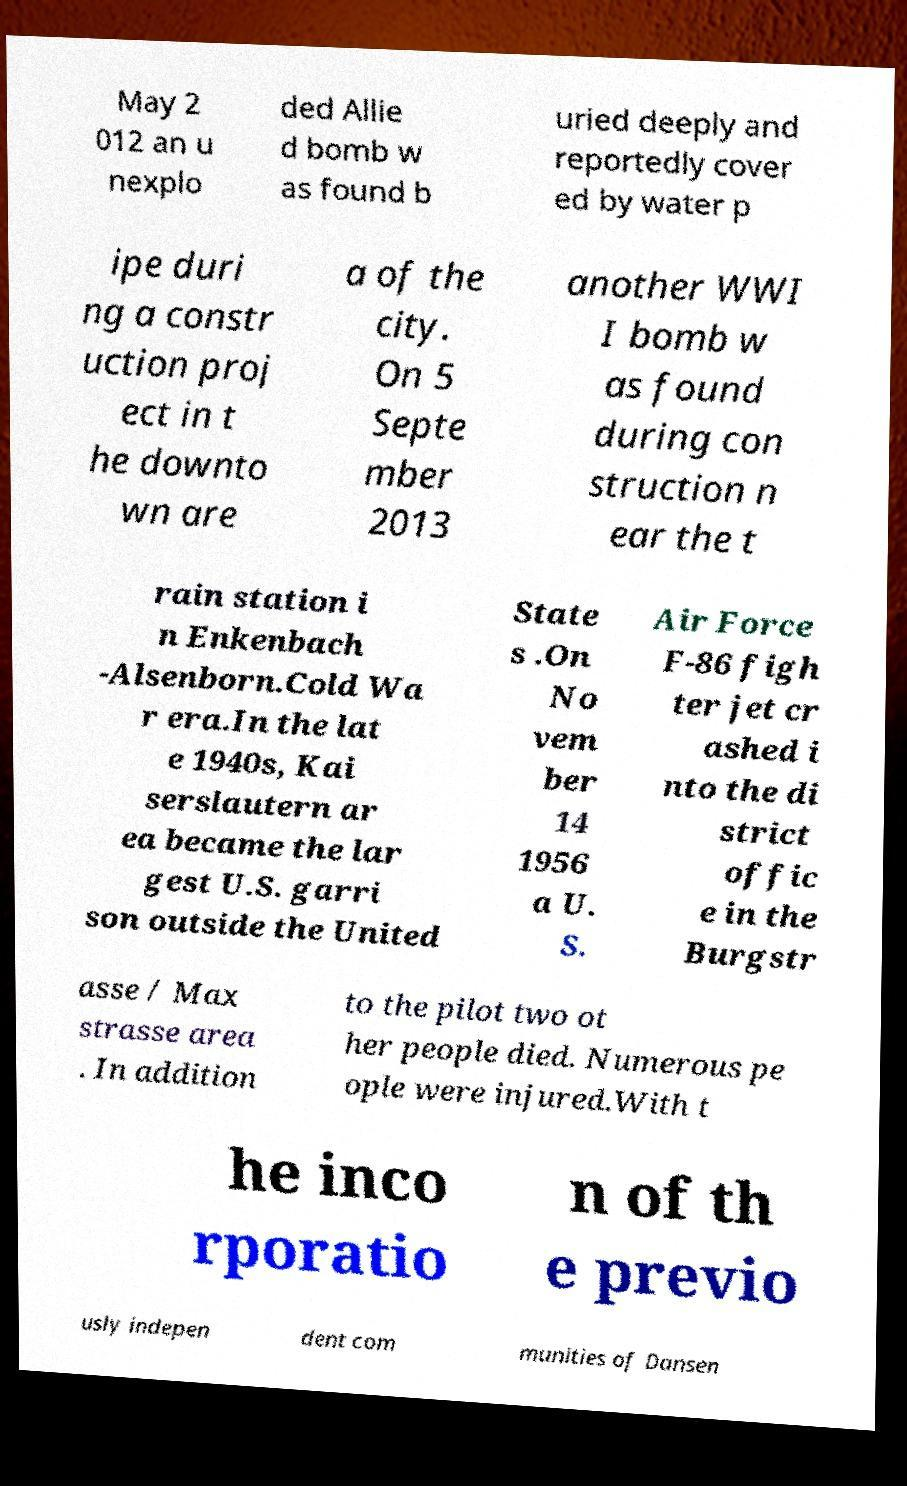Could you extract and type out the text from this image? May 2 012 an u nexplo ded Allie d bomb w as found b uried deeply and reportedly cover ed by water p ipe duri ng a constr uction proj ect in t he downto wn are a of the city. On 5 Septe mber 2013 another WWI I bomb w as found during con struction n ear the t rain station i n Enkenbach -Alsenborn.Cold Wa r era.In the lat e 1940s, Kai serslautern ar ea became the lar gest U.S. garri son outside the United State s .On No vem ber 14 1956 a U. S. Air Force F-86 figh ter jet cr ashed i nto the di strict offic e in the Burgstr asse / Max strasse area . In addition to the pilot two ot her people died. Numerous pe ople were injured.With t he inco rporatio n of th e previo usly indepen dent com munities of Dansen 